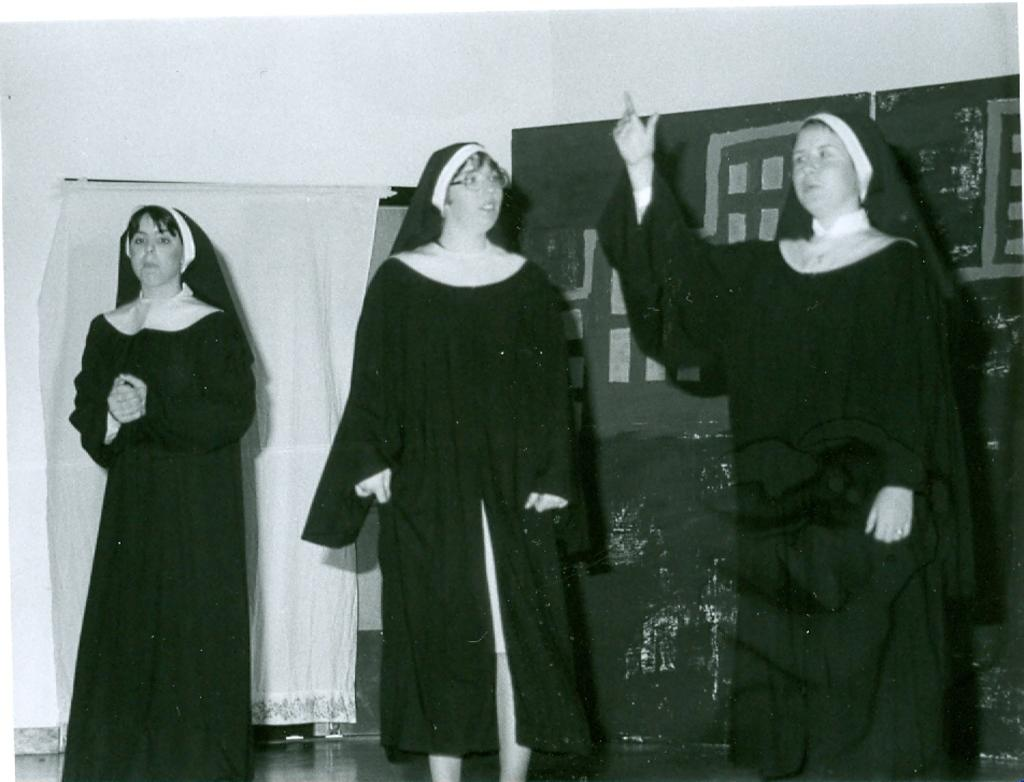What is the color scheme of the image? The image is black and white. How many people are in the image? There are three persons standing in the image. Where are the persons standing? The persons are standing on the floor. What can be seen in the background of the image? There is a curtain, a wall, and an object in the background of the image. Can you tell me how deep the river is in the image? There is no river present in the image; it is a black and white image of three persons standing on the floor with a curtain, wall, and an object in the background. 